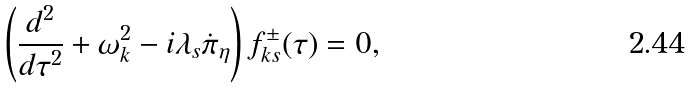<formula> <loc_0><loc_0><loc_500><loc_500>\left ( \frac { d ^ { 2 } } { d \tau ^ { 2 } } + \omega _ { k } ^ { 2 } - i \lambda _ { s } \dot { \pi } _ { \eta } \right ) f ^ { \pm } _ { { k } s } ( \tau ) = 0 ,</formula> 